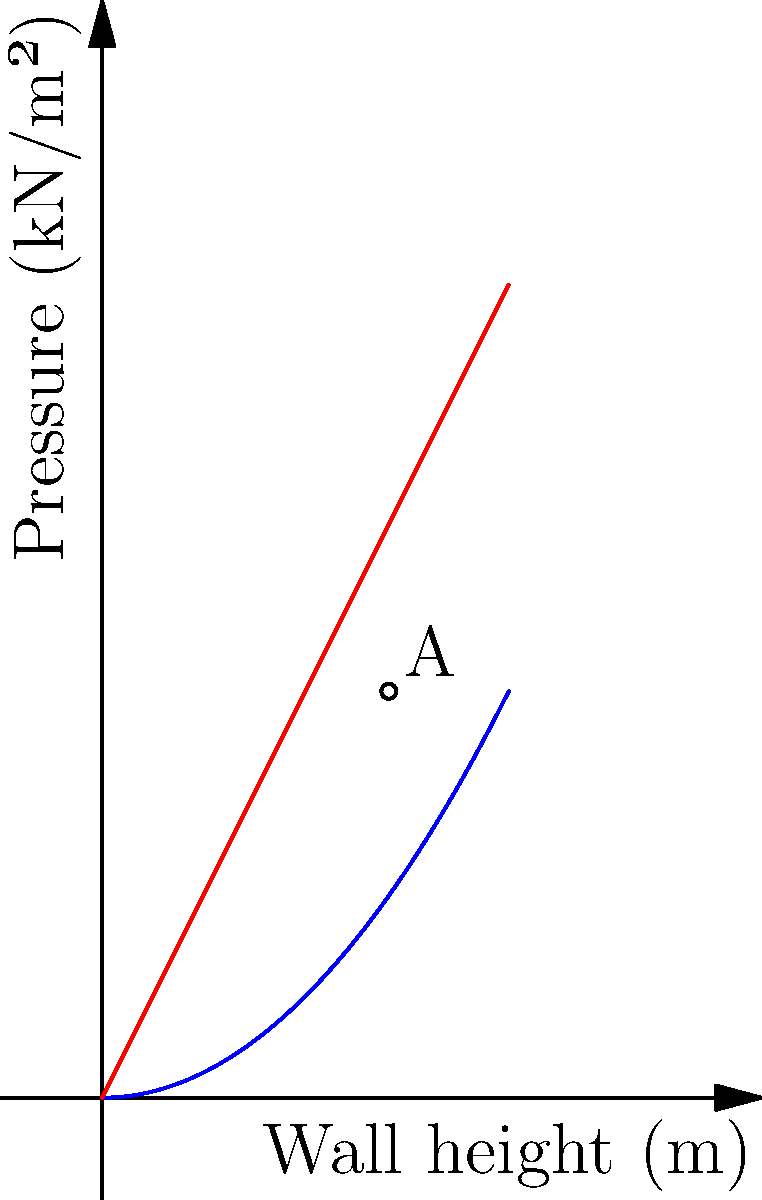In a martial arts-inspired civil engineering challenge, you're tasked with designing a retaining wall for a new dojo. The soil pressure diagram (blue curve) and wall resistance (red line) are shown above. At what wall height does the soil pressure equal the wall resistance, representing the optimal angle for the retaining wall? To solve this problem, we need to find the intersection point of the two curves:

1. Soil pressure curve (blue): $P_s = 0.5h^2$
2. Wall resistance line (red): $P_r = 2h$

At the intersection point, $P_s = P_r$:

$$0.5h^2 = 2h$$

Rearranging the equation:

$$0.5h^2 - 2h = 0$$

Multiply both sides by 2:

$$h^2 - 4h = 0$$

Factor out h:

$$h(h - 4) = 0$$

Solving for h:
$h = 0$ or $h = 4$

Since h = 0 is not a valid solution for wall height, we use h = 4.

To verify, we can substitute this value back into either equation:

$$P_s = 0.5(4)^2 = 8$$
$$P_r = 2(4) = 8$$

The intersection point occurs at (4, 8), which represents a wall height of 4 meters and a pressure of 8 kN/m².

However, the graph only shows up to 2 meters in height. The visible intersection point appears to be at approximately (1.41, 2.82).

To confirm this, we can solve:

$$0.5(1.41)^2 ≈ 2(1.41) ≈ 2.82$$

Therefore, the optimal wall height shown in the graph is approximately 1.41 meters.
Answer: 1.41 meters 